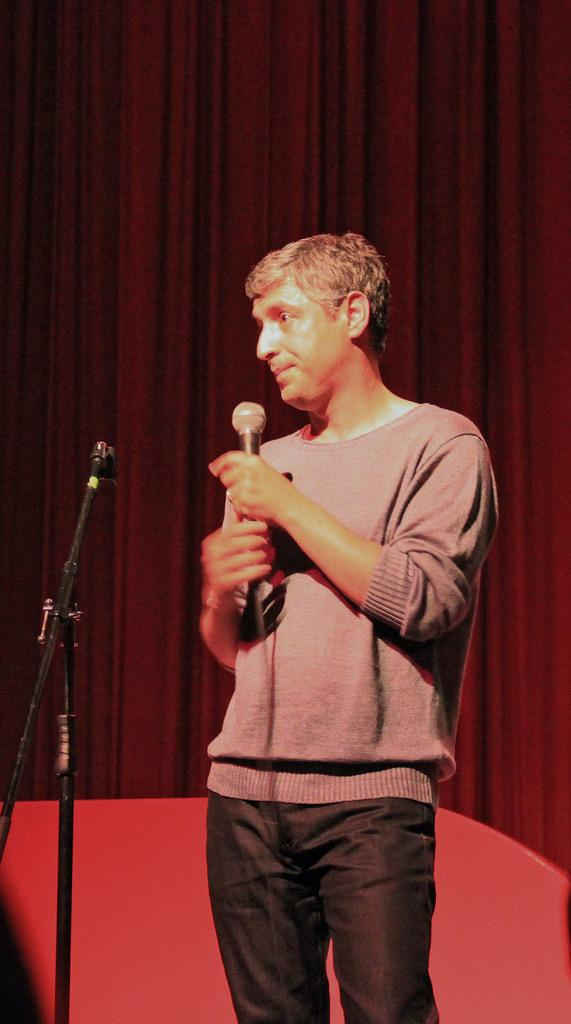What is the main subject of the image? There is a man standing in the middle of the image. What is the man holding in the image? The man is holding a microphone. What can be seen behind the man in the image? There is a curtain behind the man. How many flies can be seen on the man's shoulder in the image? There are no flies visible on the man's shoulder in the image. What type of rock is the man using to hold the microphone? The man is not using any rock to hold the microphone; he is simply holding it in his hand. 